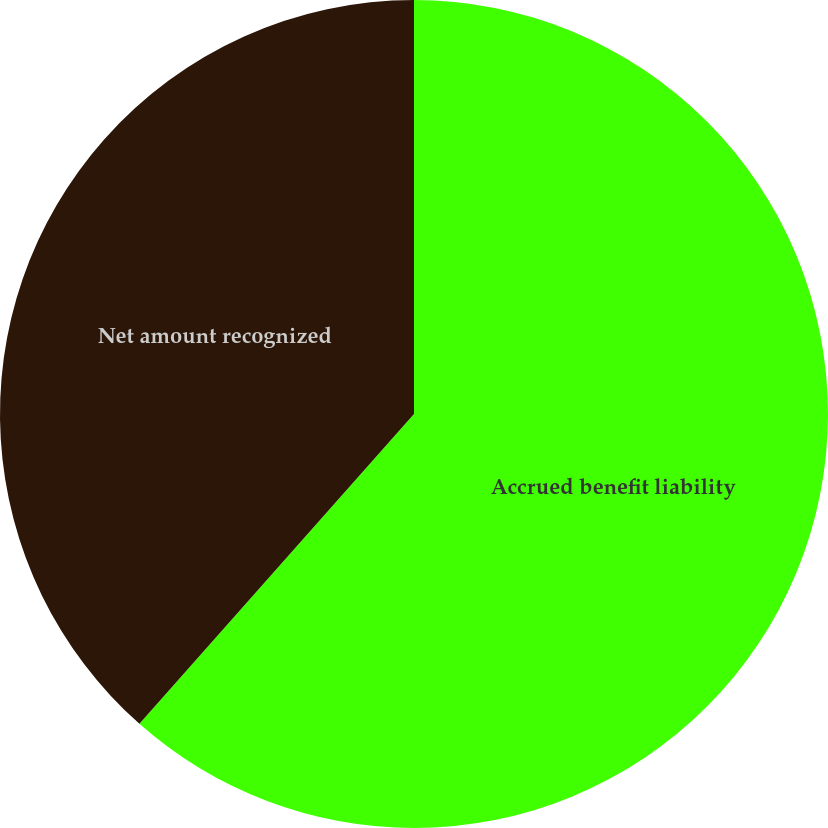<chart> <loc_0><loc_0><loc_500><loc_500><pie_chart><fcel>Accrued benefit liability<fcel>Net amount recognized<nl><fcel>61.54%<fcel>38.46%<nl></chart> 